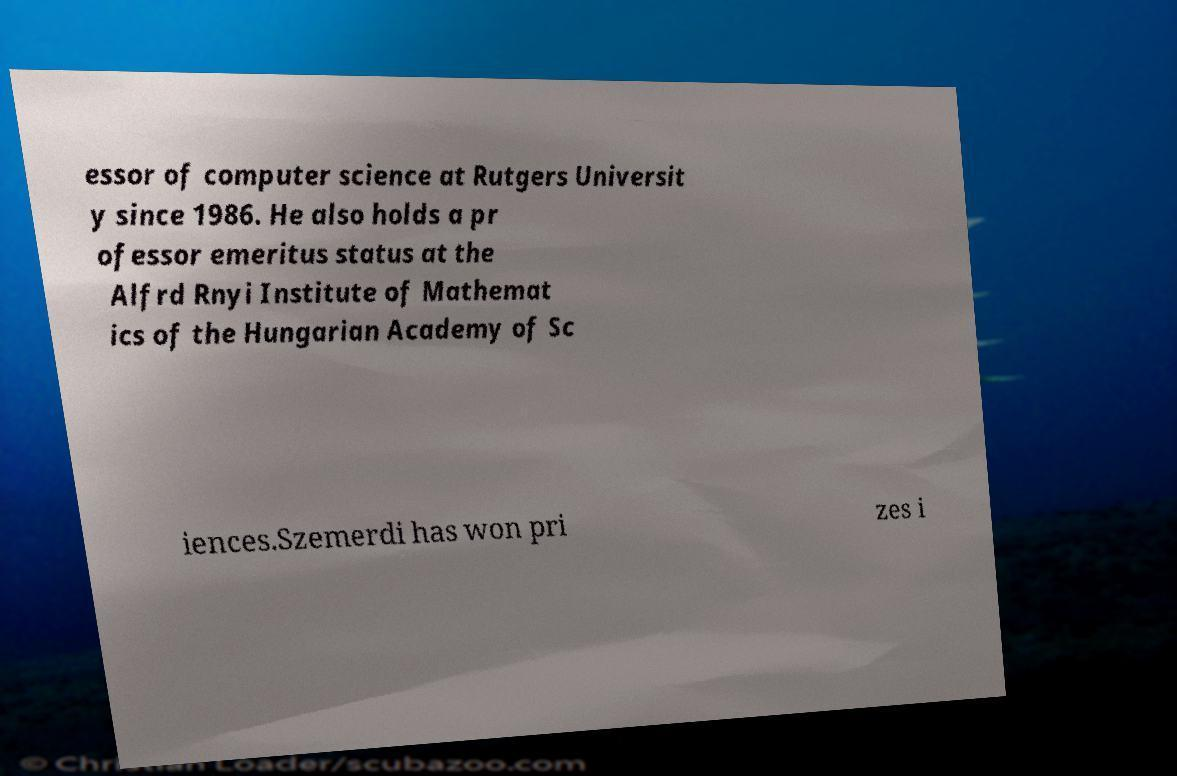Can you accurately transcribe the text from the provided image for me? essor of computer science at Rutgers Universit y since 1986. He also holds a pr ofessor emeritus status at the Alfrd Rnyi Institute of Mathemat ics of the Hungarian Academy of Sc iences.Szemerdi has won pri zes i 